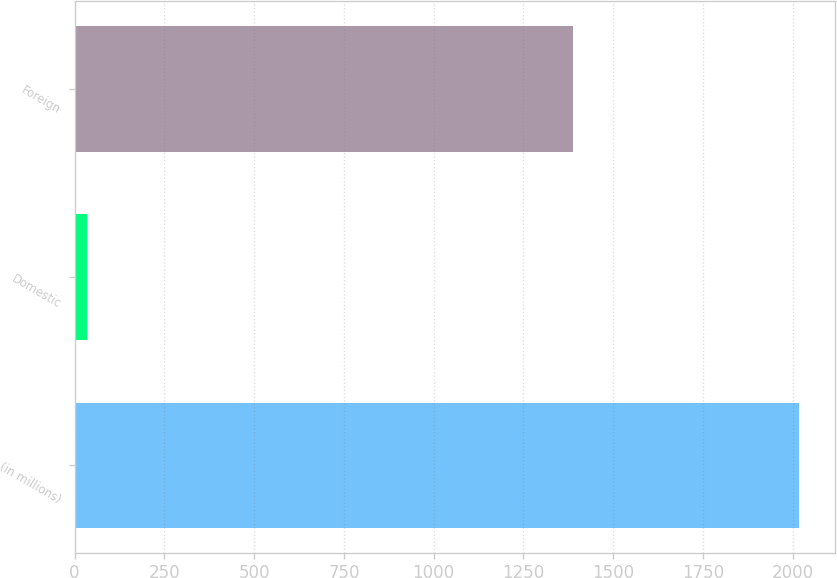<chart> <loc_0><loc_0><loc_500><loc_500><bar_chart><fcel>(in millions)<fcel>Domestic<fcel>Foreign<nl><fcel>2018<fcel>35<fcel>1387<nl></chart> 